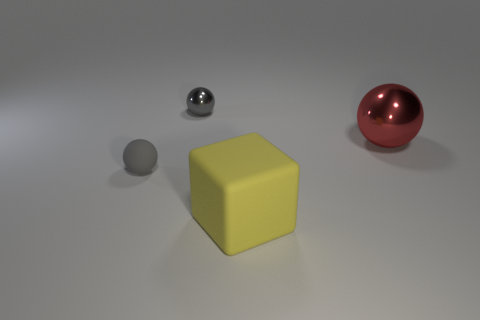Add 3 brown rubber things. How many objects exist? 7 Subtract all cubes. How many objects are left? 3 Add 1 small blue metal objects. How many small blue metal objects exist? 1 Subtract 0 blue balls. How many objects are left? 4 Subtract all rubber cylinders. Subtract all gray things. How many objects are left? 2 Add 2 cubes. How many cubes are left? 3 